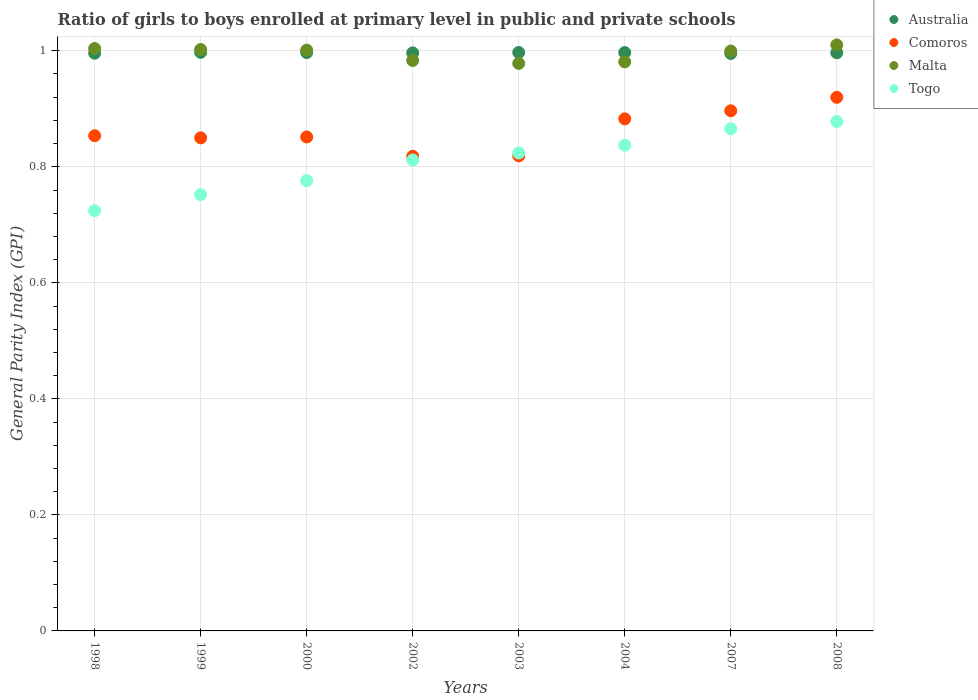Is the number of dotlines equal to the number of legend labels?
Provide a succinct answer. Yes. What is the general parity index in Australia in 2004?
Keep it short and to the point. 1. Across all years, what is the maximum general parity index in Togo?
Your answer should be compact. 0.88. Across all years, what is the minimum general parity index in Malta?
Offer a very short reply. 0.98. In which year was the general parity index in Malta maximum?
Make the answer very short. 2008. What is the total general parity index in Malta in the graph?
Keep it short and to the point. 7.96. What is the difference between the general parity index in Australia in 2002 and that in 2007?
Offer a terse response. 0. What is the difference between the general parity index in Malta in 1999 and the general parity index in Togo in 2007?
Your response must be concise. 0.14. What is the average general parity index in Togo per year?
Your response must be concise. 0.81. In the year 1999, what is the difference between the general parity index in Togo and general parity index in Malta?
Give a very brief answer. -0.25. What is the ratio of the general parity index in Comoros in 1998 to that in 2007?
Ensure brevity in your answer.  0.95. Is the general parity index in Togo in 1999 less than that in 2000?
Offer a terse response. Yes. Is the difference between the general parity index in Togo in 2002 and 2008 greater than the difference between the general parity index in Malta in 2002 and 2008?
Keep it short and to the point. No. What is the difference between the highest and the second highest general parity index in Malta?
Ensure brevity in your answer.  0.01. What is the difference between the highest and the lowest general parity index in Australia?
Keep it short and to the point. 0. In how many years, is the general parity index in Australia greater than the average general parity index in Australia taken over all years?
Your response must be concise. 4. Is the sum of the general parity index in Malta in 1999 and 2008 greater than the maximum general parity index in Comoros across all years?
Your response must be concise. Yes. Is it the case that in every year, the sum of the general parity index in Comoros and general parity index in Malta  is greater than the sum of general parity index in Australia and general parity index in Togo?
Give a very brief answer. No. Does the general parity index in Australia monotonically increase over the years?
Your response must be concise. No. Is the general parity index in Malta strictly greater than the general parity index in Comoros over the years?
Offer a very short reply. Yes. Is the general parity index in Togo strictly less than the general parity index in Comoros over the years?
Offer a very short reply. No. What is the difference between two consecutive major ticks on the Y-axis?
Give a very brief answer. 0.2. Does the graph contain any zero values?
Your response must be concise. No. What is the title of the graph?
Provide a succinct answer. Ratio of girls to boys enrolled at primary level in public and private schools. Does "Congo (Republic)" appear as one of the legend labels in the graph?
Your response must be concise. No. What is the label or title of the Y-axis?
Your answer should be very brief. General Parity Index (GPI). What is the General Parity Index (GPI) of Australia in 1998?
Provide a short and direct response. 1. What is the General Parity Index (GPI) in Comoros in 1998?
Your response must be concise. 0.85. What is the General Parity Index (GPI) of Malta in 1998?
Your answer should be compact. 1. What is the General Parity Index (GPI) in Togo in 1998?
Make the answer very short. 0.72. What is the General Parity Index (GPI) in Australia in 1999?
Provide a succinct answer. 1. What is the General Parity Index (GPI) of Comoros in 1999?
Give a very brief answer. 0.85. What is the General Parity Index (GPI) in Malta in 1999?
Your answer should be compact. 1. What is the General Parity Index (GPI) of Togo in 1999?
Your answer should be compact. 0.75. What is the General Parity Index (GPI) of Australia in 2000?
Your answer should be compact. 1. What is the General Parity Index (GPI) in Comoros in 2000?
Offer a terse response. 0.85. What is the General Parity Index (GPI) in Malta in 2000?
Your answer should be very brief. 1. What is the General Parity Index (GPI) in Togo in 2000?
Keep it short and to the point. 0.78. What is the General Parity Index (GPI) of Australia in 2002?
Provide a short and direct response. 1. What is the General Parity Index (GPI) of Comoros in 2002?
Give a very brief answer. 0.82. What is the General Parity Index (GPI) in Malta in 2002?
Give a very brief answer. 0.98. What is the General Parity Index (GPI) of Togo in 2002?
Your answer should be very brief. 0.81. What is the General Parity Index (GPI) in Australia in 2003?
Provide a succinct answer. 1. What is the General Parity Index (GPI) of Comoros in 2003?
Offer a very short reply. 0.82. What is the General Parity Index (GPI) of Malta in 2003?
Make the answer very short. 0.98. What is the General Parity Index (GPI) of Togo in 2003?
Your answer should be very brief. 0.82. What is the General Parity Index (GPI) in Australia in 2004?
Ensure brevity in your answer.  1. What is the General Parity Index (GPI) of Comoros in 2004?
Provide a short and direct response. 0.88. What is the General Parity Index (GPI) in Malta in 2004?
Your response must be concise. 0.98. What is the General Parity Index (GPI) of Togo in 2004?
Your answer should be very brief. 0.84. What is the General Parity Index (GPI) of Australia in 2007?
Your answer should be compact. 1. What is the General Parity Index (GPI) in Comoros in 2007?
Offer a terse response. 0.9. What is the General Parity Index (GPI) of Malta in 2007?
Your response must be concise. 1. What is the General Parity Index (GPI) of Togo in 2007?
Give a very brief answer. 0.87. What is the General Parity Index (GPI) of Australia in 2008?
Ensure brevity in your answer.  1. What is the General Parity Index (GPI) of Comoros in 2008?
Provide a short and direct response. 0.92. What is the General Parity Index (GPI) of Malta in 2008?
Your response must be concise. 1.01. What is the General Parity Index (GPI) in Togo in 2008?
Provide a succinct answer. 0.88. Across all years, what is the maximum General Parity Index (GPI) of Australia?
Your answer should be compact. 1. Across all years, what is the maximum General Parity Index (GPI) in Comoros?
Ensure brevity in your answer.  0.92. Across all years, what is the maximum General Parity Index (GPI) of Malta?
Keep it short and to the point. 1.01. Across all years, what is the maximum General Parity Index (GPI) in Togo?
Ensure brevity in your answer.  0.88. Across all years, what is the minimum General Parity Index (GPI) of Australia?
Your response must be concise. 1. Across all years, what is the minimum General Parity Index (GPI) of Comoros?
Keep it short and to the point. 0.82. Across all years, what is the minimum General Parity Index (GPI) of Malta?
Give a very brief answer. 0.98. Across all years, what is the minimum General Parity Index (GPI) of Togo?
Offer a very short reply. 0.72. What is the total General Parity Index (GPI) of Australia in the graph?
Provide a short and direct response. 7.97. What is the total General Parity Index (GPI) of Comoros in the graph?
Your answer should be very brief. 6.89. What is the total General Parity Index (GPI) in Malta in the graph?
Provide a short and direct response. 7.96. What is the total General Parity Index (GPI) in Togo in the graph?
Your response must be concise. 6.47. What is the difference between the General Parity Index (GPI) of Australia in 1998 and that in 1999?
Give a very brief answer. -0. What is the difference between the General Parity Index (GPI) in Comoros in 1998 and that in 1999?
Your response must be concise. 0. What is the difference between the General Parity Index (GPI) of Malta in 1998 and that in 1999?
Give a very brief answer. 0. What is the difference between the General Parity Index (GPI) in Togo in 1998 and that in 1999?
Your answer should be very brief. -0.03. What is the difference between the General Parity Index (GPI) of Australia in 1998 and that in 2000?
Provide a short and direct response. -0. What is the difference between the General Parity Index (GPI) in Comoros in 1998 and that in 2000?
Offer a terse response. 0. What is the difference between the General Parity Index (GPI) in Malta in 1998 and that in 2000?
Give a very brief answer. 0. What is the difference between the General Parity Index (GPI) in Togo in 1998 and that in 2000?
Provide a succinct answer. -0.05. What is the difference between the General Parity Index (GPI) in Australia in 1998 and that in 2002?
Give a very brief answer. -0. What is the difference between the General Parity Index (GPI) of Comoros in 1998 and that in 2002?
Give a very brief answer. 0.04. What is the difference between the General Parity Index (GPI) in Malta in 1998 and that in 2002?
Offer a terse response. 0.02. What is the difference between the General Parity Index (GPI) in Togo in 1998 and that in 2002?
Offer a terse response. -0.09. What is the difference between the General Parity Index (GPI) in Australia in 1998 and that in 2003?
Give a very brief answer. -0. What is the difference between the General Parity Index (GPI) of Comoros in 1998 and that in 2003?
Make the answer very short. 0.03. What is the difference between the General Parity Index (GPI) in Malta in 1998 and that in 2003?
Your response must be concise. 0.03. What is the difference between the General Parity Index (GPI) in Togo in 1998 and that in 2003?
Keep it short and to the point. -0.1. What is the difference between the General Parity Index (GPI) of Australia in 1998 and that in 2004?
Give a very brief answer. -0. What is the difference between the General Parity Index (GPI) of Comoros in 1998 and that in 2004?
Provide a succinct answer. -0.03. What is the difference between the General Parity Index (GPI) in Malta in 1998 and that in 2004?
Keep it short and to the point. 0.02. What is the difference between the General Parity Index (GPI) in Togo in 1998 and that in 2004?
Keep it short and to the point. -0.11. What is the difference between the General Parity Index (GPI) in Australia in 1998 and that in 2007?
Make the answer very short. 0. What is the difference between the General Parity Index (GPI) in Comoros in 1998 and that in 2007?
Keep it short and to the point. -0.04. What is the difference between the General Parity Index (GPI) in Malta in 1998 and that in 2007?
Ensure brevity in your answer.  0. What is the difference between the General Parity Index (GPI) of Togo in 1998 and that in 2007?
Keep it short and to the point. -0.14. What is the difference between the General Parity Index (GPI) of Australia in 1998 and that in 2008?
Your answer should be very brief. -0. What is the difference between the General Parity Index (GPI) in Comoros in 1998 and that in 2008?
Your response must be concise. -0.07. What is the difference between the General Parity Index (GPI) in Malta in 1998 and that in 2008?
Offer a terse response. -0.01. What is the difference between the General Parity Index (GPI) in Togo in 1998 and that in 2008?
Provide a short and direct response. -0.15. What is the difference between the General Parity Index (GPI) in Comoros in 1999 and that in 2000?
Your answer should be very brief. -0. What is the difference between the General Parity Index (GPI) in Malta in 1999 and that in 2000?
Make the answer very short. 0. What is the difference between the General Parity Index (GPI) in Togo in 1999 and that in 2000?
Keep it short and to the point. -0.02. What is the difference between the General Parity Index (GPI) in Comoros in 1999 and that in 2002?
Provide a short and direct response. 0.03. What is the difference between the General Parity Index (GPI) of Malta in 1999 and that in 2002?
Provide a short and direct response. 0.02. What is the difference between the General Parity Index (GPI) in Togo in 1999 and that in 2002?
Offer a terse response. -0.06. What is the difference between the General Parity Index (GPI) in Comoros in 1999 and that in 2003?
Ensure brevity in your answer.  0.03. What is the difference between the General Parity Index (GPI) of Malta in 1999 and that in 2003?
Make the answer very short. 0.02. What is the difference between the General Parity Index (GPI) in Togo in 1999 and that in 2003?
Provide a succinct answer. -0.07. What is the difference between the General Parity Index (GPI) in Comoros in 1999 and that in 2004?
Offer a terse response. -0.03. What is the difference between the General Parity Index (GPI) in Malta in 1999 and that in 2004?
Your response must be concise. 0.02. What is the difference between the General Parity Index (GPI) in Togo in 1999 and that in 2004?
Your answer should be compact. -0.09. What is the difference between the General Parity Index (GPI) of Australia in 1999 and that in 2007?
Your answer should be compact. 0. What is the difference between the General Parity Index (GPI) in Comoros in 1999 and that in 2007?
Give a very brief answer. -0.05. What is the difference between the General Parity Index (GPI) in Malta in 1999 and that in 2007?
Your answer should be very brief. 0. What is the difference between the General Parity Index (GPI) in Togo in 1999 and that in 2007?
Offer a very short reply. -0.11. What is the difference between the General Parity Index (GPI) of Australia in 1999 and that in 2008?
Give a very brief answer. 0. What is the difference between the General Parity Index (GPI) of Comoros in 1999 and that in 2008?
Give a very brief answer. -0.07. What is the difference between the General Parity Index (GPI) of Malta in 1999 and that in 2008?
Provide a succinct answer. -0.01. What is the difference between the General Parity Index (GPI) of Togo in 1999 and that in 2008?
Offer a very short reply. -0.13. What is the difference between the General Parity Index (GPI) in Comoros in 2000 and that in 2002?
Offer a very short reply. 0.03. What is the difference between the General Parity Index (GPI) of Malta in 2000 and that in 2002?
Give a very brief answer. 0.02. What is the difference between the General Parity Index (GPI) of Togo in 2000 and that in 2002?
Ensure brevity in your answer.  -0.04. What is the difference between the General Parity Index (GPI) of Australia in 2000 and that in 2003?
Your answer should be compact. -0. What is the difference between the General Parity Index (GPI) in Comoros in 2000 and that in 2003?
Make the answer very short. 0.03. What is the difference between the General Parity Index (GPI) of Malta in 2000 and that in 2003?
Make the answer very short. 0.02. What is the difference between the General Parity Index (GPI) in Togo in 2000 and that in 2003?
Provide a short and direct response. -0.05. What is the difference between the General Parity Index (GPI) in Australia in 2000 and that in 2004?
Your response must be concise. 0. What is the difference between the General Parity Index (GPI) in Comoros in 2000 and that in 2004?
Provide a short and direct response. -0.03. What is the difference between the General Parity Index (GPI) in Malta in 2000 and that in 2004?
Ensure brevity in your answer.  0.02. What is the difference between the General Parity Index (GPI) in Togo in 2000 and that in 2004?
Provide a succinct answer. -0.06. What is the difference between the General Parity Index (GPI) in Australia in 2000 and that in 2007?
Give a very brief answer. 0. What is the difference between the General Parity Index (GPI) in Comoros in 2000 and that in 2007?
Your answer should be very brief. -0.05. What is the difference between the General Parity Index (GPI) in Malta in 2000 and that in 2007?
Offer a terse response. 0. What is the difference between the General Parity Index (GPI) in Togo in 2000 and that in 2007?
Offer a terse response. -0.09. What is the difference between the General Parity Index (GPI) in Australia in 2000 and that in 2008?
Provide a short and direct response. 0. What is the difference between the General Parity Index (GPI) in Comoros in 2000 and that in 2008?
Provide a short and direct response. -0.07. What is the difference between the General Parity Index (GPI) of Malta in 2000 and that in 2008?
Ensure brevity in your answer.  -0.01. What is the difference between the General Parity Index (GPI) in Togo in 2000 and that in 2008?
Provide a short and direct response. -0.1. What is the difference between the General Parity Index (GPI) of Australia in 2002 and that in 2003?
Your answer should be compact. -0. What is the difference between the General Parity Index (GPI) in Comoros in 2002 and that in 2003?
Give a very brief answer. -0. What is the difference between the General Parity Index (GPI) of Malta in 2002 and that in 2003?
Your response must be concise. 0.01. What is the difference between the General Parity Index (GPI) of Togo in 2002 and that in 2003?
Your response must be concise. -0.01. What is the difference between the General Parity Index (GPI) in Australia in 2002 and that in 2004?
Provide a succinct answer. -0. What is the difference between the General Parity Index (GPI) of Comoros in 2002 and that in 2004?
Offer a terse response. -0.06. What is the difference between the General Parity Index (GPI) in Malta in 2002 and that in 2004?
Your answer should be compact. 0. What is the difference between the General Parity Index (GPI) in Togo in 2002 and that in 2004?
Your answer should be compact. -0.03. What is the difference between the General Parity Index (GPI) of Australia in 2002 and that in 2007?
Your answer should be compact. 0. What is the difference between the General Parity Index (GPI) of Comoros in 2002 and that in 2007?
Make the answer very short. -0.08. What is the difference between the General Parity Index (GPI) in Malta in 2002 and that in 2007?
Keep it short and to the point. -0.02. What is the difference between the General Parity Index (GPI) of Togo in 2002 and that in 2007?
Your answer should be compact. -0.05. What is the difference between the General Parity Index (GPI) of Australia in 2002 and that in 2008?
Ensure brevity in your answer.  -0. What is the difference between the General Parity Index (GPI) in Comoros in 2002 and that in 2008?
Offer a terse response. -0.1. What is the difference between the General Parity Index (GPI) in Malta in 2002 and that in 2008?
Provide a short and direct response. -0.03. What is the difference between the General Parity Index (GPI) of Togo in 2002 and that in 2008?
Ensure brevity in your answer.  -0.07. What is the difference between the General Parity Index (GPI) in Comoros in 2003 and that in 2004?
Give a very brief answer. -0.06. What is the difference between the General Parity Index (GPI) in Malta in 2003 and that in 2004?
Provide a succinct answer. -0. What is the difference between the General Parity Index (GPI) in Togo in 2003 and that in 2004?
Keep it short and to the point. -0.01. What is the difference between the General Parity Index (GPI) of Australia in 2003 and that in 2007?
Offer a terse response. 0. What is the difference between the General Parity Index (GPI) of Comoros in 2003 and that in 2007?
Make the answer very short. -0.08. What is the difference between the General Parity Index (GPI) of Malta in 2003 and that in 2007?
Offer a terse response. -0.02. What is the difference between the General Parity Index (GPI) in Togo in 2003 and that in 2007?
Give a very brief answer. -0.04. What is the difference between the General Parity Index (GPI) of Comoros in 2003 and that in 2008?
Your answer should be very brief. -0.1. What is the difference between the General Parity Index (GPI) of Malta in 2003 and that in 2008?
Offer a very short reply. -0.03. What is the difference between the General Parity Index (GPI) of Togo in 2003 and that in 2008?
Your answer should be compact. -0.05. What is the difference between the General Parity Index (GPI) in Australia in 2004 and that in 2007?
Your answer should be compact. 0. What is the difference between the General Parity Index (GPI) in Comoros in 2004 and that in 2007?
Keep it short and to the point. -0.01. What is the difference between the General Parity Index (GPI) of Malta in 2004 and that in 2007?
Offer a terse response. -0.02. What is the difference between the General Parity Index (GPI) in Togo in 2004 and that in 2007?
Make the answer very short. -0.03. What is the difference between the General Parity Index (GPI) of Comoros in 2004 and that in 2008?
Your answer should be compact. -0.04. What is the difference between the General Parity Index (GPI) of Malta in 2004 and that in 2008?
Keep it short and to the point. -0.03. What is the difference between the General Parity Index (GPI) in Togo in 2004 and that in 2008?
Make the answer very short. -0.04. What is the difference between the General Parity Index (GPI) in Australia in 2007 and that in 2008?
Offer a very short reply. -0. What is the difference between the General Parity Index (GPI) of Comoros in 2007 and that in 2008?
Provide a short and direct response. -0.02. What is the difference between the General Parity Index (GPI) of Malta in 2007 and that in 2008?
Ensure brevity in your answer.  -0.01. What is the difference between the General Parity Index (GPI) in Togo in 2007 and that in 2008?
Provide a succinct answer. -0.01. What is the difference between the General Parity Index (GPI) in Australia in 1998 and the General Parity Index (GPI) in Comoros in 1999?
Provide a short and direct response. 0.15. What is the difference between the General Parity Index (GPI) in Australia in 1998 and the General Parity Index (GPI) in Malta in 1999?
Give a very brief answer. -0.01. What is the difference between the General Parity Index (GPI) of Australia in 1998 and the General Parity Index (GPI) of Togo in 1999?
Give a very brief answer. 0.24. What is the difference between the General Parity Index (GPI) in Comoros in 1998 and the General Parity Index (GPI) in Malta in 1999?
Your response must be concise. -0.15. What is the difference between the General Parity Index (GPI) of Comoros in 1998 and the General Parity Index (GPI) of Togo in 1999?
Your answer should be compact. 0.1. What is the difference between the General Parity Index (GPI) of Malta in 1998 and the General Parity Index (GPI) of Togo in 1999?
Your response must be concise. 0.25. What is the difference between the General Parity Index (GPI) of Australia in 1998 and the General Parity Index (GPI) of Comoros in 2000?
Your response must be concise. 0.14. What is the difference between the General Parity Index (GPI) in Australia in 1998 and the General Parity Index (GPI) in Malta in 2000?
Ensure brevity in your answer.  -0.01. What is the difference between the General Parity Index (GPI) in Australia in 1998 and the General Parity Index (GPI) in Togo in 2000?
Provide a succinct answer. 0.22. What is the difference between the General Parity Index (GPI) of Comoros in 1998 and the General Parity Index (GPI) of Malta in 2000?
Offer a very short reply. -0.15. What is the difference between the General Parity Index (GPI) in Comoros in 1998 and the General Parity Index (GPI) in Togo in 2000?
Your answer should be very brief. 0.08. What is the difference between the General Parity Index (GPI) in Malta in 1998 and the General Parity Index (GPI) in Togo in 2000?
Offer a terse response. 0.23. What is the difference between the General Parity Index (GPI) in Australia in 1998 and the General Parity Index (GPI) in Comoros in 2002?
Make the answer very short. 0.18. What is the difference between the General Parity Index (GPI) in Australia in 1998 and the General Parity Index (GPI) in Malta in 2002?
Keep it short and to the point. 0.01. What is the difference between the General Parity Index (GPI) of Australia in 1998 and the General Parity Index (GPI) of Togo in 2002?
Provide a short and direct response. 0.18. What is the difference between the General Parity Index (GPI) in Comoros in 1998 and the General Parity Index (GPI) in Malta in 2002?
Offer a very short reply. -0.13. What is the difference between the General Parity Index (GPI) in Comoros in 1998 and the General Parity Index (GPI) in Togo in 2002?
Offer a terse response. 0.04. What is the difference between the General Parity Index (GPI) in Malta in 1998 and the General Parity Index (GPI) in Togo in 2002?
Keep it short and to the point. 0.19. What is the difference between the General Parity Index (GPI) of Australia in 1998 and the General Parity Index (GPI) of Comoros in 2003?
Your response must be concise. 0.18. What is the difference between the General Parity Index (GPI) in Australia in 1998 and the General Parity Index (GPI) in Malta in 2003?
Provide a short and direct response. 0.02. What is the difference between the General Parity Index (GPI) in Australia in 1998 and the General Parity Index (GPI) in Togo in 2003?
Offer a terse response. 0.17. What is the difference between the General Parity Index (GPI) of Comoros in 1998 and the General Parity Index (GPI) of Malta in 2003?
Ensure brevity in your answer.  -0.12. What is the difference between the General Parity Index (GPI) of Comoros in 1998 and the General Parity Index (GPI) of Togo in 2003?
Keep it short and to the point. 0.03. What is the difference between the General Parity Index (GPI) in Malta in 1998 and the General Parity Index (GPI) in Togo in 2003?
Provide a short and direct response. 0.18. What is the difference between the General Parity Index (GPI) in Australia in 1998 and the General Parity Index (GPI) in Comoros in 2004?
Offer a very short reply. 0.11. What is the difference between the General Parity Index (GPI) of Australia in 1998 and the General Parity Index (GPI) of Malta in 2004?
Make the answer very short. 0.01. What is the difference between the General Parity Index (GPI) of Australia in 1998 and the General Parity Index (GPI) of Togo in 2004?
Ensure brevity in your answer.  0.16. What is the difference between the General Parity Index (GPI) in Comoros in 1998 and the General Parity Index (GPI) in Malta in 2004?
Your response must be concise. -0.13. What is the difference between the General Parity Index (GPI) of Comoros in 1998 and the General Parity Index (GPI) of Togo in 2004?
Keep it short and to the point. 0.02. What is the difference between the General Parity Index (GPI) of Australia in 1998 and the General Parity Index (GPI) of Comoros in 2007?
Ensure brevity in your answer.  0.1. What is the difference between the General Parity Index (GPI) of Australia in 1998 and the General Parity Index (GPI) of Malta in 2007?
Provide a short and direct response. -0. What is the difference between the General Parity Index (GPI) in Australia in 1998 and the General Parity Index (GPI) in Togo in 2007?
Give a very brief answer. 0.13. What is the difference between the General Parity Index (GPI) of Comoros in 1998 and the General Parity Index (GPI) of Malta in 2007?
Give a very brief answer. -0.15. What is the difference between the General Parity Index (GPI) of Comoros in 1998 and the General Parity Index (GPI) of Togo in 2007?
Ensure brevity in your answer.  -0.01. What is the difference between the General Parity Index (GPI) in Malta in 1998 and the General Parity Index (GPI) in Togo in 2007?
Provide a succinct answer. 0.14. What is the difference between the General Parity Index (GPI) in Australia in 1998 and the General Parity Index (GPI) in Comoros in 2008?
Offer a terse response. 0.08. What is the difference between the General Parity Index (GPI) in Australia in 1998 and the General Parity Index (GPI) in Malta in 2008?
Offer a terse response. -0.01. What is the difference between the General Parity Index (GPI) in Australia in 1998 and the General Parity Index (GPI) in Togo in 2008?
Give a very brief answer. 0.12. What is the difference between the General Parity Index (GPI) of Comoros in 1998 and the General Parity Index (GPI) of Malta in 2008?
Your response must be concise. -0.16. What is the difference between the General Parity Index (GPI) in Comoros in 1998 and the General Parity Index (GPI) in Togo in 2008?
Your answer should be compact. -0.02. What is the difference between the General Parity Index (GPI) in Malta in 1998 and the General Parity Index (GPI) in Togo in 2008?
Your response must be concise. 0.13. What is the difference between the General Parity Index (GPI) of Australia in 1999 and the General Parity Index (GPI) of Comoros in 2000?
Provide a short and direct response. 0.15. What is the difference between the General Parity Index (GPI) in Australia in 1999 and the General Parity Index (GPI) in Malta in 2000?
Provide a short and direct response. -0. What is the difference between the General Parity Index (GPI) in Australia in 1999 and the General Parity Index (GPI) in Togo in 2000?
Keep it short and to the point. 0.22. What is the difference between the General Parity Index (GPI) in Comoros in 1999 and the General Parity Index (GPI) in Malta in 2000?
Keep it short and to the point. -0.15. What is the difference between the General Parity Index (GPI) in Comoros in 1999 and the General Parity Index (GPI) in Togo in 2000?
Offer a terse response. 0.07. What is the difference between the General Parity Index (GPI) in Malta in 1999 and the General Parity Index (GPI) in Togo in 2000?
Your answer should be compact. 0.23. What is the difference between the General Parity Index (GPI) of Australia in 1999 and the General Parity Index (GPI) of Comoros in 2002?
Ensure brevity in your answer.  0.18. What is the difference between the General Parity Index (GPI) in Australia in 1999 and the General Parity Index (GPI) in Malta in 2002?
Offer a very short reply. 0.01. What is the difference between the General Parity Index (GPI) of Australia in 1999 and the General Parity Index (GPI) of Togo in 2002?
Ensure brevity in your answer.  0.19. What is the difference between the General Parity Index (GPI) of Comoros in 1999 and the General Parity Index (GPI) of Malta in 2002?
Provide a succinct answer. -0.13. What is the difference between the General Parity Index (GPI) of Comoros in 1999 and the General Parity Index (GPI) of Togo in 2002?
Ensure brevity in your answer.  0.04. What is the difference between the General Parity Index (GPI) of Malta in 1999 and the General Parity Index (GPI) of Togo in 2002?
Make the answer very short. 0.19. What is the difference between the General Parity Index (GPI) in Australia in 1999 and the General Parity Index (GPI) in Comoros in 2003?
Provide a succinct answer. 0.18. What is the difference between the General Parity Index (GPI) in Australia in 1999 and the General Parity Index (GPI) in Malta in 2003?
Your answer should be very brief. 0.02. What is the difference between the General Parity Index (GPI) of Australia in 1999 and the General Parity Index (GPI) of Togo in 2003?
Your answer should be compact. 0.17. What is the difference between the General Parity Index (GPI) of Comoros in 1999 and the General Parity Index (GPI) of Malta in 2003?
Your answer should be compact. -0.13. What is the difference between the General Parity Index (GPI) in Comoros in 1999 and the General Parity Index (GPI) in Togo in 2003?
Keep it short and to the point. 0.03. What is the difference between the General Parity Index (GPI) of Malta in 1999 and the General Parity Index (GPI) of Togo in 2003?
Offer a terse response. 0.18. What is the difference between the General Parity Index (GPI) of Australia in 1999 and the General Parity Index (GPI) of Comoros in 2004?
Your answer should be very brief. 0.11. What is the difference between the General Parity Index (GPI) of Australia in 1999 and the General Parity Index (GPI) of Malta in 2004?
Offer a terse response. 0.02. What is the difference between the General Parity Index (GPI) in Australia in 1999 and the General Parity Index (GPI) in Togo in 2004?
Offer a terse response. 0.16. What is the difference between the General Parity Index (GPI) of Comoros in 1999 and the General Parity Index (GPI) of Malta in 2004?
Provide a succinct answer. -0.13. What is the difference between the General Parity Index (GPI) of Comoros in 1999 and the General Parity Index (GPI) of Togo in 2004?
Keep it short and to the point. 0.01. What is the difference between the General Parity Index (GPI) in Malta in 1999 and the General Parity Index (GPI) in Togo in 2004?
Make the answer very short. 0.17. What is the difference between the General Parity Index (GPI) of Australia in 1999 and the General Parity Index (GPI) of Comoros in 2007?
Provide a succinct answer. 0.1. What is the difference between the General Parity Index (GPI) of Australia in 1999 and the General Parity Index (GPI) of Malta in 2007?
Give a very brief answer. -0. What is the difference between the General Parity Index (GPI) of Australia in 1999 and the General Parity Index (GPI) of Togo in 2007?
Provide a short and direct response. 0.13. What is the difference between the General Parity Index (GPI) in Comoros in 1999 and the General Parity Index (GPI) in Malta in 2007?
Your answer should be very brief. -0.15. What is the difference between the General Parity Index (GPI) in Comoros in 1999 and the General Parity Index (GPI) in Togo in 2007?
Your answer should be very brief. -0.02. What is the difference between the General Parity Index (GPI) of Malta in 1999 and the General Parity Index (GPI) of Togo in 2007?
Your answer should be very brief. 0.14. What is the difference between the General Parity Index (GPI) in Australia in 1999 and the General Parity Index (GPI) in Comoros in 2008?
Keep it short and to the point. 0.08. What is the difference between the General Parity Index (GPI) of Australia in 1999 and the General Parity Index (GPI) of Malta in 2008?
Ensure brevity in your answer.  -0.01. What is the difference between the General Parity Index (GPI) in Australia in 1999 and the General Parity Index (GPI) in Togo in 2008?
Offer a very short reply. 0.12. What is the difference between the General Parity Index (GPI) in Comoros in 1999 and the General Parity Index (GPI) in Malta in 2008?
Ensure brevity in your answer.  -0.16. What is the difference between the General Parity Index (GPI) of Comoros in 1999 and the General Parity Index (GPI) of Togo in 2008?
Provide a succinct answer. -0.03. What is the difference between the General Parity Index (GPI) in Malta in 1999 and the General Parity Index (GPI) in Togo in 2008?
Make the answer very short. 0.12. What is the difference between the General Parity Index (GPI) in Australia in 2000 and the General Parity Index (GPI) in Comoros in 2002?
Provide a succinct answer. 0.18. What is the difference between the General Parity Index (GPI) in Australia in 2000 and the General Parity Index (GPI) in Malta in 2002?
Provide a short and direct response. 0.01. What is the difference between the General Parity Index (GPI) in Australia in 2000 and the General Parity Index (GPI) in Togo in 2002?
Provide a succinct answer. 0.19. What is the difference between the General Parity Index (GPI) of Comoros in 2000 and the General Parity Index (GPI) of Malta in 2002?
Ensure brevity in your answer.  -0.13. What is the difference between the General Parity Index (GPI) of Comoros in 2000 and the General Parity Index (GPI) of Togo in 2002?
Offer a terse response. 0.04. What is the difference between the General Parity Index (GPI) in Malta in 2000 and the General Parity Index (GPI) in Togo in 2002?
Provide a succinct answer. 0.19. What is the difference between the General Parity Index (GPI) in Australia in 2000 and the General Parity Index (GPI) in Comoros in 2003?
Keep it short and to the point. 0.18. What is the difference between the General Parity Index (GPI) of Australia in 2000 and the General Parity Index (GPI) of Malta in 2003?
Offer a very short reply. 0.02. What is the difference between the General Parity Index (GPI) in Australia in 2000 and the General Parity Index (GPI) in Togo in 2003?
Offer a terse response. 0.17. What is the difference between the General Parity Index (GPI) of Comoros in 2000 and the General Parity Index (GPI) of Malta in 2003?
Give a very brief answer. -0.13. What is the difference between the General Parity Index (GPI) of Comoros in 2000 and the General Parity Index (GPI) of Togo in 2003?
Keep it short and to the point. 0.03. What is the difference between the General Parity Index (GPI) in Malta in 2000 and the General Parity Index (GPI) in Togo in 2003?
Give a very brief answer. 0.18. What is the difference between the General Parity Index (GPI) in Australia in 2000 and the General Parity Index (GPI) in Comoros in 2004?
Your answer should be very brief. 0.11. What is the difference between the General Parity Index (GPI) in Australia in 2000 and the General Parity Index (GPI) in Malta in 2004?
Your answer should be compact. 0.02. What is the difference between the General Parity Index (GPI) of Australia in 2000 and the General Parity Index (GPI) of Togo in 2004?
Offer a terse response. 0.16. What is the difference between the General Parity Index (GPI) of Comoros in 2000 and the General Parity Index (GPI) of Malta in 2004?
Give a very brief answer. -0.13. What is the difference between the General Parity Index (GPI) of Comoros in 2000 and the General Parity Index (GPI) of Togo in 2004?
Provide a short and direct response. 0.01. What is the difference between the General Parity Index (GPI) of Malta in 2000 and the General Parity Index (GPI) of Togo in 2004?
Your response must be concise. 0.16. What is the difference between the General Parity Index (GPI) in Australia in 2000 and the General Parity Index (GPI) in Comoros in 2007?
Provide a short and direct response. 0.1. What is the difference between the General Parity Index (GPI) in Australia in 2000 and the General Parity Index (GPI) in Malta in 2007?
Provide a succinct answer. -0. What is the difference between the General Parity Index (GPI) in Australia in 2000 and the General Parity Index (GPI) in Togo in 2007?
Your response must be concise. 0.13. What is the difference between the General Parity Index (GPI) of Comoros in 2000 and the General Parity Index (GPI) of Malta in 2007?
Offer a very short reply. -0.15. What is the difference between the General Parity Index (GPI) in Comoros in 2000 and the General Parity Index (GPI) in Togo in 2007?
Provide a short and direct response. -0.01. What is the difference between the General Parity Index (GPI) of Malta in 2000 and the General Parity Index (GPI) of Togo in 2007?
Your answer should be compact. 0.14. What is the difference between the General Parity Index (GPI) in Australia in 2000 and the General Parity Index (GPI) in Comoros in 2008?
Give a very brief answer. 0.08. What is the difference between the General Parity Index (GPI) in Australia in 2000 and the General Parity Index (GPI) in Malta in 2008?
Ensure brevity in your answer.  -0.01. What is the difference between the General Parity Index (GPI) in Australia in 2000 and the General Parity Index (GPI) in Togo in 2008?
Your answer should be very brief. 0.12. What is the difference between the General Parity Index (GPI) of Comoros in 2000 and the General Parity Index (GPI) of Malta in 2008?
Ensure brevity in your answer.  -0.16. What is the difference between the General Parity Index (GPI) in Comoros in 2000 and the General Parity Index (GPI) in Togo in 2008?
Provide a succinct answer. -0.03. What is the difference between the General Parity Index (GPI) of Malta in 2000 and the General Parity Index (GPI) of Togo in 2008?
Your answer should be very brief. 0.12. What is the difference between the General Parity Index (GPI) of Australia in 2002 and the General Parity Index (GPI) of Comoros in 2003?
Your answer should be very brief. 0.18. What is the difference between the General Parity Index (GPI) of Australia in 2002 and the General Parity Index (GPI) of Malta in 2003?
Provide a succinct answer. 0.02. What is the difference between the General Parity Index (GPI) in Australia in 2002 and the General Parity Index (GPI) in Togo in 2003?
Offer a terse response. 0.17. What is the difference between the General Parity Index (GPI) in Comoros in 2002 and the General Parity Index (GPI) in Malta in 2003?
Give a very brief answer. -0.16. What is the difference between the General Parity Index (GPI) of Comoros in 2002 and the General Parity Index (GPI) of Togo in 2003?
Provide a short and direct response. -0.01. What is the difference between the General Parity Index (GPI) of Malta in 2002 and the General Parity Index (GPI) of Togo in 2003?
Provide a succinct answer. 0.16. What is the difference between the General Parity Index (GPI) in Australia in 2002 and the General Parity Index (GPI) in Comoros in 2004?
Provide a short and direct response. 0.11. What is the difference between the General Parity Index (GPI) of Australia in 2002 and the General Parity Index (GPI) of Malta in 2004?
Make the answer very short. 0.02. What is the difference between the General Parity Index (GPI) in Australia in 2002 and the General Parity Index (GPI) in Togo in 2004?
Make the answer very short. 0.16. What is the difference between the General Parity Index (GPI) in Comoros in 2002 and the General Parity Index (GPI) in Malta in 2004?
Offer a terse response. -0.16. What is the difference between the General Parity Index (GPI) in Comoros in 2002 and the General Parity Index (GPI) in Togo in 2004?
Provide a succinct answer. -0.02. What is the difference between the General Parity Index (GPI) in Malta in 2002 and the General Parity Index (GPI) in Togo in 2004?
Offer a very short reply. 0.15. What is the difference between the General Parity Index (GPI) of Australia in 2002 and the General Parity Index (GPI) of Comoros in 2007?
Offer a very short reply. 0.1. What is the difference between the General Parity Index (GPI) of Australia in 2002 and the General Parity Index (GPI) of Malta in 2007?
Offer a terse response. -0. What is the difference between the General Parity Index (GPI) in Australia in 2002 and the General Parity Index (GPI) in Togo in 2007?
Your answer should be very brief. 0.13. What is the difference between the General Parity Index (GPI) in Comoros in 2002 and the General Parity Index (GPI) in Malta in 2007?
Offer a very short reply. -0.18. What is the difference between the General Parity Index (GPI) in Comoros in 2002 and the General Parity Index (GPI) in Togo in 2007?
Offer a very short reply. -0.05. What is the difference between the General Parity Index (GPI) of Malta in 2002 and the General Parity Index (GPI) of Togo in 2007?
Ensure brevity in your answer.  0.12. What is the difference between the General Parity Index (GPI) in Australia in 2002 and the General Parity Index (GPI) in Comoros in 2008?
Offer a terse response. 0.08. What is the difference between the General Parity Index (GPI) of Australia in 2002 and the General Parity Index (GPI) of Malta in 2008?
Provide a succinct answer. -0.01. What is the difference between the General Parity Index (GPI) of Australia in 2002 and the General Parity Index (GPI) of Togo in 2008?
Your answer should be very brief. 0.12. What is the difference between the General Parity Index (GPI) in Comoros in 2002 and the General Parity Index (GPI) in Malta in 2008?
Make the answer very short. -0.19. What is the difference between the General Parity Index (GPI) in Comoros in 2002 and the General Parity Index (GPI) in Togo in 2008?
Ensure brevity in your answer.  -0.06. What is the difference between the General Parity Index (GPI) in Malta in 2002 and the General Parity Index (GPI) in Togo in 2008?
Provide a short and direct response. 0.11. What is the difference between the General Parity Index (GPI) of Australia in 2003 and the General Parity Index (GPI) of Comoros in 2004?
Your response must be concise. 0.11. What is the difference between the General Parity Index (GPI) in Australia in 2003 and the General Parity Index (GPI) in Malta in 2004?
Ensure brevity in your answer.  0.02. What is the difference between the General Parity Index (GPI) of Australia in 2003 and the General Parity Index (GPI) of Togo in 2004?
Your response must be concise. 0.16. What is the difference between the General Parity Index (GPI) of Comoros in 2003 and the General Parity Index (GPI) of Malta in 2004?
Keep it short and to the point. -0.16. What is the difference between the General Parity Index (GPI) of Comoros in 2003 and the General Parity Index (GPI) of Togo in 2004?
Ensure brevity in your answer.  -0.02. What is the difference between the General Parity Index (GPI) in Malta in 2003 and the General Parity Index (GPI) in Togo in 2004?
Offer a very short reply. 0.14. What is the difference between the General Parity Index (GPI) of Australia in 2003 and the General Parity Index (GPI) of Comoros in 2007?
Keep it short and to the point. 0.1. What is the difference between the General Parity Index (GPI) of Australia in 2003 and the General Parity Index (GPI) of Malta in 2007?
Provide a succinct answer. -0. What is the difference between the General Parity Index (GPI) of Australia in 2003 and the General Parity Index (GPI) of Togo in 2007?
Your response must be concise. 0.13. What is the difference between the General Parity Index (GPI) of Comoros in 2003 and the General Parity Index (GPI) of Malta in 2007?
Keep it short and to the point. -0.18. What is the difference between the General Parity Index (GPI) of Comoros in 2003 and the General Parity Index (GPI) of Togo in 2007?
Your answer should be very brief. -0.05. What is the difference between the General Parity Index (GPI) of Malta in 2003 and the General Parity Index (GPI) of Togo in 2007?
Ensure brevity in your answer.  0.11. What is the difference between the General Parity Index (GPI) of Australia in 2003 and the General Parity Index (GPI) of Comoros in 2008?
Offer a very short reply. 0.08. What is the difference between the General Parity Index (GPI) in Australia in 2003 and the General Parity Index (GPI) in Malta in 2008?
Ensure brevity in your answer.  -0.01. What is the difference between the General Parity Index (GPI) in Australia in 2003 and the General Parity Index (GPI) in Togo in 2008?
Provide a succinct answer. 0.12. What is the difference between the General Parity Index (GPI) of Comoros in 2003 and the General Parity Index (GPI) of Malta in 2008?
Offer a terse response. -0.19. What is the difference between the General Parity Index (GPI) of Comoros in 2003 and the General Parity Index (GPI) of Togo in 2008?
Provide a short and direct response. -0.06. What is the difference between the General Parity Index (GPI) of Malta in 2003 and the General Parity Index (GPI) of Togo in 2008?
Your answer should be very brief. 0.1. What is the difference between the General Parity Index (GPI) of Australia in 2004 and the General Parity Index (GPI) of Comoros in 2007?
Your answer should be very brief. 0.1. What is the difference between the General Parity Index (GPI) of Australia in 2004 and the General Parity Index (GPI) of Malta in 2007?
Your answer should be compact. -0. What is the difference between the General Parity Index (GPI) in Australia in 2004 and the General Parity Index (GPI) in Togo in 2007?
Ensure brevity in your answer.  0.13. What is the difference between the General Parity Index (GPI) in Comoros in 2004 and the General Parity Index (GPI) in Malta in 2007?
Offer a very short reply. -0.12. What is the difference between the General Parity Index (GPI) of Comoros in 2004 and the General Parity Index (GPI) of Togo in 2007?
Offer a very short reply. 0.02. What is the difference between the General Parity Index (GPI) of Malta in 2004 and the General Parity Index (GPI) of Togo in 2007?
Offer a very short reply. 0.12. What is the difference between the General Parity Index (GPI) of Australia in 2004 and the General Parity Index (GPI) of Comoros in 2008?
Your answer should be very brief. 0.08. What is the difference between the General Parity Index (GPI) of Australia in 2004 and the General Parity Index (GPI) of Malta in 2008?
Ensure brevity in your answer.  -0.01. What is the difference between the General Parity Index (GPI) of Australia in 2004 and the General Parity Index (GPI) of Togo in 2008?
Make the answer very short. 0.12. What is the difference between the General Parity Index (GPI) of Comoros in 2004 and the General Parity Index (GPI) of Malta in 2008?
Offer a terse response. -0.13. What is the difference between the General Parity Index (GPI) in Comoros in 2004 and the General Parity Index (GPI) in Togo in 2008?
Offer a terse response. 0. What is the difference between the General Parity Index (GPI) in Malta in 2004 and the General Parity Index (GPI) in Togo in 2008?
Offer a terse response. 0.1. What is the difference between the General Parity Index (GPI) in Australia in 2007 and the General Parity Index (GPI) in Comoros in 2008?
Your answer should be very brief. 0.08. What is the difference between the General Parity Index (GPI) in Australia in 2007 and the General Parity Index (GPI) in Malta in 2008?
Offer a terse response. -0.01. What is the difference between the General Parity Index (GPI) in Australia in 2007 and the General Parity Index (GPI) in Togo in 2008?
Your answer should be very brief. 0.12. What is the difference between the General Parity Index (GPI) in Comoros in 2007 and the General Parity Index (GPI) in Malta in 2008?
Ensure brevity in your answer.  -0.11. What is the difference between the General Parity Index (GPI) in Comoros in 2007 and the General Parity Index (GPI) in Togo in 2008?
Provide a succinct answer. 0.02. What is the difference between the General Parity Index (GPI) in Malta in 2007 and the General Parity Index (GPI) in Togo in 2008?
Provide a succinct answer. 0.12. What is the average General Parity Index (GPI) of Australia per year?
Ensure brevity in your answer.  1. What is the average General Parity Index (GPI) of Comoros per year?
Ensure brevity in your answer.  0.86. What is the average General Parity Index (GPI) in Togo per year?
Provide a short and direct response. 0.81. In the year 1998, what is the difference between the General Parity Index (GPI) in Australia and General Parity Index (GPI) in Comoros?
Provide a short and direct response. 0.14. In the year 1998, what is the difference between the General Parity Index (GPI) in Australia and General Parity Index (GPI) in Malta?
Offer a terse response. -0.01. In the year 1998, what is the difference between the General Parity Index (GPI) in Australia and General Parity Index (GPI) in Togo?
Offer a terse response. 0.27. In the year 1998, what is the difference between the General Parity Index (GPI) of Comoros and General Parity Index (GPI) of Malta?
Make the answer very short. -0.15. In the year 1998, what is the difference between the General Parity Index (GPI) of Comoros and General Parity Index (GPI) of Togo?
Your answer should be compact. 0.13. In the year 1998, what is the difference between the General Parity Index (GPI) in Malta and General Parity Index (GPI) in Togo?
Offer a very short reply. 0.28. In the year 1999, what is the difference between the General Parity Index (GPI) in Australia and General Parity Index (GPI) in Comoros?
Your answer should be very brief. 0.15. In the year 1999, what is the difference between the General Parity Index (GPI) of Australia and General Parity Index (GPI) of Malta?
Offer a terse response. -0. In the year 1999, what is the difference between the General Parity Index (GPI) in Australia and General Parity Index (GPI) in Togo?
Give a very brief answer. 0.25. In the year 1999, what is the difference between the General Parity Index (GPI) in Comoros and General Parity Index (GPI) in Malta?
Offer a very short reply. -0.15. In the year 1999, what is the difference between the General Parity Index (GPI) of Comoros and General Parity Index (GPI) of Togo?
Offer a very short reply. 0.1. In the year 1999, what is the difference between the General Parity Index (GPI) in Malta and General Parity Index (GPI) in Togo?
Your answer should be compact. 0.25. In the year 2000, what is the difference between the General Parity Index (GPI) in Australia and General Parity Index (GPI) in Comoros?
Your answer should be compact. 0.15. In the year 2000, what is the difference between the General Parity Index (GPI) of Australia and General Parity Index (GPI) of Malta?
Ensure brevity in your answer.  -0. In the year 2000, what is the difference between the General Parity Index (GPI) in Australia and General Parity Index (GPI) in Togo?
Keep it short and to the point. 0.22. In the year 2000, what is the difference between the General Parity Index (GPI) in Comoros and General Parity Index (GPI) in Malta?
Make the answer very short. -0.15. In the year 2000, what is the difference between the General Parity Index (GPI) of Comoros and General Parity Index (GPI) of Togo?
Keep it short and to the point. 0.08. In the year 2000, what is the difference between the General Parity Index (GPI) in Malta and General Parity Index (GPI) in Togo?
Your response must be concise. 0.23. In the year 2002, what is the difference between the General Parity Index (GPI) of Australia and General Parity Index (GPI) of Comoros?
Offer a very short reply. 0.18. In the year 2002, what is the difference between the General Parity Index (GPI) of Australia and General Parity Index (GPI) of Malta?
Make the answer very short. 0.01. In the year 2002, what is the difference between the General Parity Index (GPI) of Australia and General Parity Index (GPI) of Togo?
Offer a very short reply. 0.18. In the year 2002, what is the difference between the General Parity Index (GPI) in Comoros and General Parity Index (GPI) in Malta?
Your answer should be compact. -0.17. In the year 2002, what is the difference between the General Parity Index (GPI) in Comoros and General Parity Index (GPI) in Togo?
Your answer should be very brief. 0.01. In the year 2002, what is the difference between the General Parity Index (GPI) in Malta and General Parity Index (GPI) in Togo?
Ensure brevity in your answer.  0.17. In the year 2003, what is the difference between the General Parity Index (GPI) of Australia and General Parity Index (GPI) of Comoros?
Ensure brevity in your answer.  0.18. In the year 2003, what is the difference between the General Parity Index (GPI) of Australia and General Parity Index (GPI) of Malta?
Your response must be concise. 0.02. In the year 2003, what is the difference between the General Parity Index (GPI) of Australia and General Parity Index (GPI) of Togo?
Provide a succinct answer. 0.17. In the year 2003, what is the difference between the General Parity Index (GPI) of Comoros and General Parity Index (GPI) of Malta?
Your answer should be compact. -0.16. In the year 2003, what is the difference between the General Parity Index (GPI) in Comoros and General Parity Index (GPI) in Togo?
Keep it short and to the point. -0.01. In the year 2003, what is the difference between the General Parity Index (GPI) in Malta and General Parity Index (GPI) in Togo?
Provide a short and direct response. 0.15. In the year 2004, what is the difference between the General Parity Index (GPI) of Australia and General Parity Index (GPI) of Comoros?
Your response must be concise. 0.11. In the year 2004, what is the difference between the General Parity Index (GPI) of Australia and General Parity Index (GPI) of Malta?
Your response must be concise. 0.02. In the year 2004, what is the difference between the General Parity Index (GPI) of Australia and General Parity Index (GPI) of Togo?
Your answer should be very brief. 0.16. In the year 2004, what is the difference between the General Parity Index (GPI) in Comoros and General Parity Index (GPI) in Malta?
Offer a very short reply. -0.1. In the year 2004, what is the difference between the General Parity Index (GPI) in Comoros and General Parity Index (GPI) in Togo?
Provide a short and direct response. 0.05. In the year 2004, what is the difference between the General Parity Index (GPI) of Malta and General Parity Index (GPI) of Togo?
Keep it short and to the point. 0.14. In the year 2007, what is the difference between the General Parity Index (GPI) of Australia and General Parity Index (GPI) of Comoros?
Your response must be concise. 0.1. In the year 2007, what is the difference between the General Parity Index (GPI) in Australia and General Parity Index (GPI) in Malta?
Ensure brevity in your answer.  -0. In the year 2007, what is the difference between the General Parity Index (GPI) in Australia and General Parity Index (GPI) in Togo?
Give a very brief answer. 0.13. In the year 2007, what is the difference between the General Parity Index (GPI) of Comoros and General Parity Index (GPI) of Malta?
Make the answer very short. -0.1. In the year 2007, what is the difference between the General Parity Index (GPI) of Comoros and General Parity Index (GPI) of Togo?
Ensure brevity in your answer.  0.03. In the year 2007, what is the difference between the General Parity Index (GPI) of Malta and General Parity Index (GPI) of Togo?
Your answer should be compact. 0.13. In the year 2008, what is the difference between the General Parity Index (GPI) of Australia and General Parity Index (GPI) of Comoros?
Your answer should be compact. 0.08. In the year 2008, what is the difference between the General Parity Index (GPI) in Australia and General Parity Index (GPI) in Malta?
Your answer should be compact. -0.01. In the year 2008, what is the difference between the General Parity Index (GPI) in Australia and General Parity Index (GPI) in Togo?
Offer a terse response. 0.12. In the year 2008, what is the difference between the General Parity Index (GPI) in Comoros and General Parity Index (GPI) in Malta?
Your answer should be very brief. -0.09. In the year 2008, what is the difference between the General Parity Index (GPI) in Comoros and General Parity Index (GPI) in Togo?
Your answer should be compact. 0.04. In the year 2008, what is the difference between the General Parity Index (GPI) in Malta and General Parity Index (GPI) in Togo?
Provide a short and direct response. 0.13. What is the ratio of the General Parity Index (GPI) of Comoros in 1998 to that in 1999?
Give a very brief answer. 1. What is the ratio of the General Parity Index (GPI) in Togo in 1998 to that in 1999?
Provide a succinct answer. 0.96. What is the ratio of the General Parity Index (GPI) of Togo in 1998 to that in 2000?
Your response must be concise. 0.93. What is the ratio of the General Parity Index (GPI) of Comoros in 1998 to that in 2002?
Make the answer very short. 1.04. What is the ratio of the General Parity Index (GPI) in Malta in 1998 to that in 2002?
Offer a terse response. 1.02. What is the ratio of the General Parity Index (GPI) of Togo in 1998 to that in 2002?
Offer a terse response. 0.89. What is the ratio of the General Parity Index (GPI) in Australia in 1998 to that in 2003?
Ensure brevity in your answer.  1. What is the ratio of the General Parity Index (GPI) of Comoros in 1998 to that in 2003?
Keep it short and to the point. 1.04. What is the ratio of the General Parity Index (GPI) of Malta in 1998 to that in 2003?
Provide a succinct answer. 1.03. What is the ratio of the General Parity Index (GPI) of Togo in 1998 to that in 2003?
Offer a terse response. 0.88. What is the ratio of the General Parity Index (GPI) in Australia in 1998 to that in 2004?
Your response must be concise. 1. What is the ratio of the General Parity Index (GPI) in Comoros in 1998 to that in 2004?
Offer a terse response. 0.97. What is the ratio of the General Parity Index (GPI) in Malta in 1998 to that in 2004?
Ensure brevity in your answer.  1.02. What is the ratio of the General Parity Index (GPI) of Togo in 1998 to that in 2004?
Offer a terse response. 0.87. What is the ratio of the General Parity Index (GPI) in Togo in 1998 to that in 2007?
Provide a short and direct response. 0.84. What is the ratio of the General Parity Index (GPI) of Australia in 1998 to that in 2008?
Provide a short and direct response. 1. What is the ratio of the General Parity Index (GPI) in Comoros in 1998 to that in 2008?
Your response must be concise. 0.93. What is the ratio of the General Parity Index (GPI) in Togo in 1998 to that in 2008?
Ensure brevity in your answer.  0.83. What is the ratio of the General Parity Index (GPI) of Comoros in 1999 to that in 2000?
Your answer should be very brief. 1. What is the ratio of the General Parity Index (GPI) in Malta in 1999 to that in 2000?
Ensure brevity in your answer.  1. What is the ratio of the General Parity Index (GPI) in Togo in 1999 to that in 2000?
Your answer should be very brief. 0.97. What is the ratio of the General Parity Index (GPI) of Australia in 1999 to that in 2002?
Make the answer very short. 1. What is the ratio of the General Parity Index (GPI) of Comoros in 1999 to that in 2002?
Offer a terse response. 1.04. What is the ratio of the General Parity Index (GPI) of Malta in 1999 to that in 2002?
Provide a succinct answer. 1.02. What is the ratio of the General Parity Index (GPI) in Togo in 1999 to that in 2002?
Provide a short and direct response. 0.93. What is the ratio of the General Parity Index (GPI) in Australia in 1999 to that in 2003?
Make the answer very short. 1. What is the ratio of the General Parity Index (GPI) in Comoros in 1999 to that in 2003?
Provide a succinct answer. 1.04. What is the ratio of the General Parity Index (GPI) in Malta in 1999 to that in 2003?
Provide a short and direct response. 1.02. What is the ratio of the General Parity Index (GPI) of Comoros in 1999 to that in 2004?
Keep it short and to the point. 0.96. What is the ratio of the General Parity Index (GPI) of Malta in 1999 to that in 2004?
Offer a terse response. 1.02. What is the ratio of the General Parity Index (GPI) in Togo in 1999 to that in 2004?
Your answer should be very brief. 0.9. What is the ratio of the General Parity Index (GPI) in Australia in 1999 to that in 2007?
Keep it short and to the point. 1. What is the ratio of the General Parity Index (GPI) in Comoros in 1999 to that in 2007?
Offer a terse response. 0.95. What is the ratio of the General Parity Index (GPI) of Togo in 1999 to that in 2007?
Keep it short and to the point. 0.87. What is the ratio of the General Parity Index (GPI) in Australia in 1999 to that in 2008?
Your answer should be very brief. 1. What is the ratio of the General Parity Index (GPI) in Comoros in 1999 to that in 2008?
Ensure brevity in your answer.  0.92. What is the ratio of the General Parity Index (GPI) in Malta in 1999 to that in 2008?
Offer a terse response. 0.99. What is the ratio of the General Parity Index (GPI) in Togo in 1999 to that in 2008?
Provide a succinct answer. 0.86. What is the ratio of the General Parity Index (GPI) of Australia in 2000 to that in 2002?
Your answer should be compact. 1. What is the ratio of the General Parity Index (GPI) in Comoros in 2000 to that in 2002?
Make the answer very short. 1.04. What is the ratio of the General Parity Index (GPI) of Malta in 2000 to that in 2002?
Provide a short and direct response. 1.02. What is the ratio of the General Parity Index (GPI) of Togo in 2000 to that in 2002?
Provide a succinct answer. 0.96. What is the ratio of the General Parity Index (GPI) in Comoros in 2000 to that in 2003?
Your answer should be very brief. 1.04. What is the ratio of the General Parity Index (GPI) in Malta in 2000 to that in 2003?
Offer a terse response. 1.02. What is the ratio of the General Parity Index (GPI) in Togo in 2000 to that in 2003?
Your answer should be compact. 0.94. What is the ratio of the General Parity Index (GPI) of Comoros in 2000 to that in 2004?
Make the answer very short. 0.96. What is the ratio of the General Parity Index (GPI) of Malta in 2000 to that in 2004?
Ensure brevity in your answer.  1.02. What is the ratio of the General Parity Index (GPI) of Togo in 2000 to that in 2004?
Ensure brevity in your answer.  0.93. What is the ratio of the General Parity Index (GPI) in Comoros in 2000 to that in 2007?
Keep it short and to the point. 0.95. What is the ratio of the General Parity Index (GPI) in Malta in 2000 to that in 2007?
Ensure brevity in your answer.  1. What is the ratio of the General Parity Index (GPI) in Togo in 2000 to that in 2007?
Ensure brevity in your answer.  0.9. What is the ratio of the General Parity Index (GPI) of Comoros in 2000 to that in 2008?
Ensure brevity in your answer.  0.93. What is the ratio of the General Parity Index (GPI) in Togo in 2000 to that in 2008?
Make the answer very short. 0.88. What is the ratio of the General Parity Index (GPI) in Australia in 2002 to that in 2003?
Provide a succinct answer. 1. What is the ratio of the General Parity Index (GPI) of Comoros in 2002 to that in 2003?
Provide a short and direct response. 1. What is the ratio of the General Parity Index (GPI) of Togo in 2002 to that in 2003?
Offer a terse response. 0.99. What is the ratio of the General Parity Index (GPI) of Comoros in 2002 to that in 2004?
Provide a short and direct response. 0.93. What is the ratio of the General Parity Index (GPI) in Togo in 2002 to that in 2004?
Provide a short and direct response. 0.97. What is the ratio of the General Parity Index (GPI) of Australia in 2002 to that in 2007?
Offer a very short reply. 1. What is the ratio of the General Parity Index (GPI) of Comoros in 2002 to that in 2007?
Make the answer very short. 0.91. What is the ratio of the General Parity Index (GPI) of Malta in 2002 to that in 2007?
Your answer should be very brief. 0.98. What is the ratio of the General Parity Index (GPI) in Togo in 2002 to that in 2007?
Make the answer very short. 0.94. What is the ratio of the General Parity Index (GPI) in Australia in 2002 to that in 2008?
Make the answer very short. 1. What is the ratio of the General Parity Index (GPI) of Comoros in 2002 to that in 2008?
Your answer should be compact. 0.89. What is the ratio of the General Parity Index (GPI) of Malta in 2002 to that in 2008?
Give a very brief answer. 0.97. What is the ratio of the General Parity Index (GPI) of Togo in 2002 to that in 2008?
Your answer should be compact. 0.92. What is the ratio of the General Parity Index (GPI) in Comoros in 2003 to that in 2004?
Offer a terse response. 0.93. What is the ratio of the General Parity Index (GPI) in Togo in 2003 to that in 2004?
Ensure brevity in your answer.  0.98. What is the ratio of the General Parity Index (GPI) of Comoros in 2003 to that in 2007?
Keep it short and to the point. 0.91. What is the ratio of the General Parity Index (GPI) of Malta in 2003 to that in 2007?
Ensure brevity in your answer.  0.98. What is the ratio of the General Parity Index (GPI) in Togo in 2003 to that in 2007?
Your answer should be compact. 0.95. What is the ratio of the General Parity Index (GPI) of Australia in 2003 to that in 2008?
Your answer should be very brief. 1. What is the ratio of the General Parity Index (GPI) of Comoros in 2003 to that in 2008?
Your answer should be very brief. 0.89. What is the ratio of the General Parity Index (GPI) of Malta in 2003 to that in 2008?
Give a very brief answer. 0.97. What is the ratio of the General Parity Index (GPI) of Togo in 2003 to that in 2008?
Offer a very short reply. 0.94. What is the ratio of the General Parity Index (GPI) in Comoros in 2004 to that in 2007?
Provide a succinct answer. 0.98. What is the ratio of the General Parity Index (GPI) in Malta in 2004 to that in 2007?
Your answer should be very brief. 0.98. What is the ratio of the General Parity Index (GPI) in Togo in 2004 to that in 2007?
Provide a short and direct response. 0.97. What is the ratio of the General Parity Index (GPI) of Comoros in 2004 to that in 2008?
Ensure brevity in your answer.  0.96. What is the ratio of the General Parity Index (GPI) of Togo in 2004 to that in 2008?
Offer a very short reply. 0.95. What is the ratio of the General Parity Index (GPI) of Comoros in 2007 to that in 2008?
Give a very brief answer. 0.97. What is the ratio of the General Parity Index (GPI) in Malta in 2007 to that in 2008?
Your answer should be compact. 0.99. What is the ratio of the General Parity Index (GPI) in Togo in 2007 to that in 2008?
Provide a short and direct response. 0.99. What is the difference between the highest and the second highest General Parity Index (GPI) in Comoros?
Offer a terse response. 0.02. What is the difference between the highest and the second highest General Parity Index (GPI) in Malta?
Give a very brief answer. 0.01. What is the difference between the highest and the second highest General Parity Index (GPI) in Togo?
Ensure brevity in your answer.  0.01. What is the difference between the highest and the lowest General Parity Index (GPI) in Australia?
Provide a short and direct response. 0. What is the difference between the highest and the lowest General Parity Index (GPI) in Comoros?
Make the answer very short. 0.1. What is the difference between the highest and the lowest General Parity Index (GPI) of Malta?
Your answer should be very brief. 0.03. What is the difference between the highest and the lowest General Parity Index (GPI) in Togo?
Offer a terse response. 0.15. 